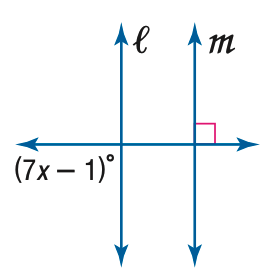Question: Find x so that m \parallel n.
Choices:
A. 10
B. 11
C. 12
D. 13
Answer with the letter. Answer: D 